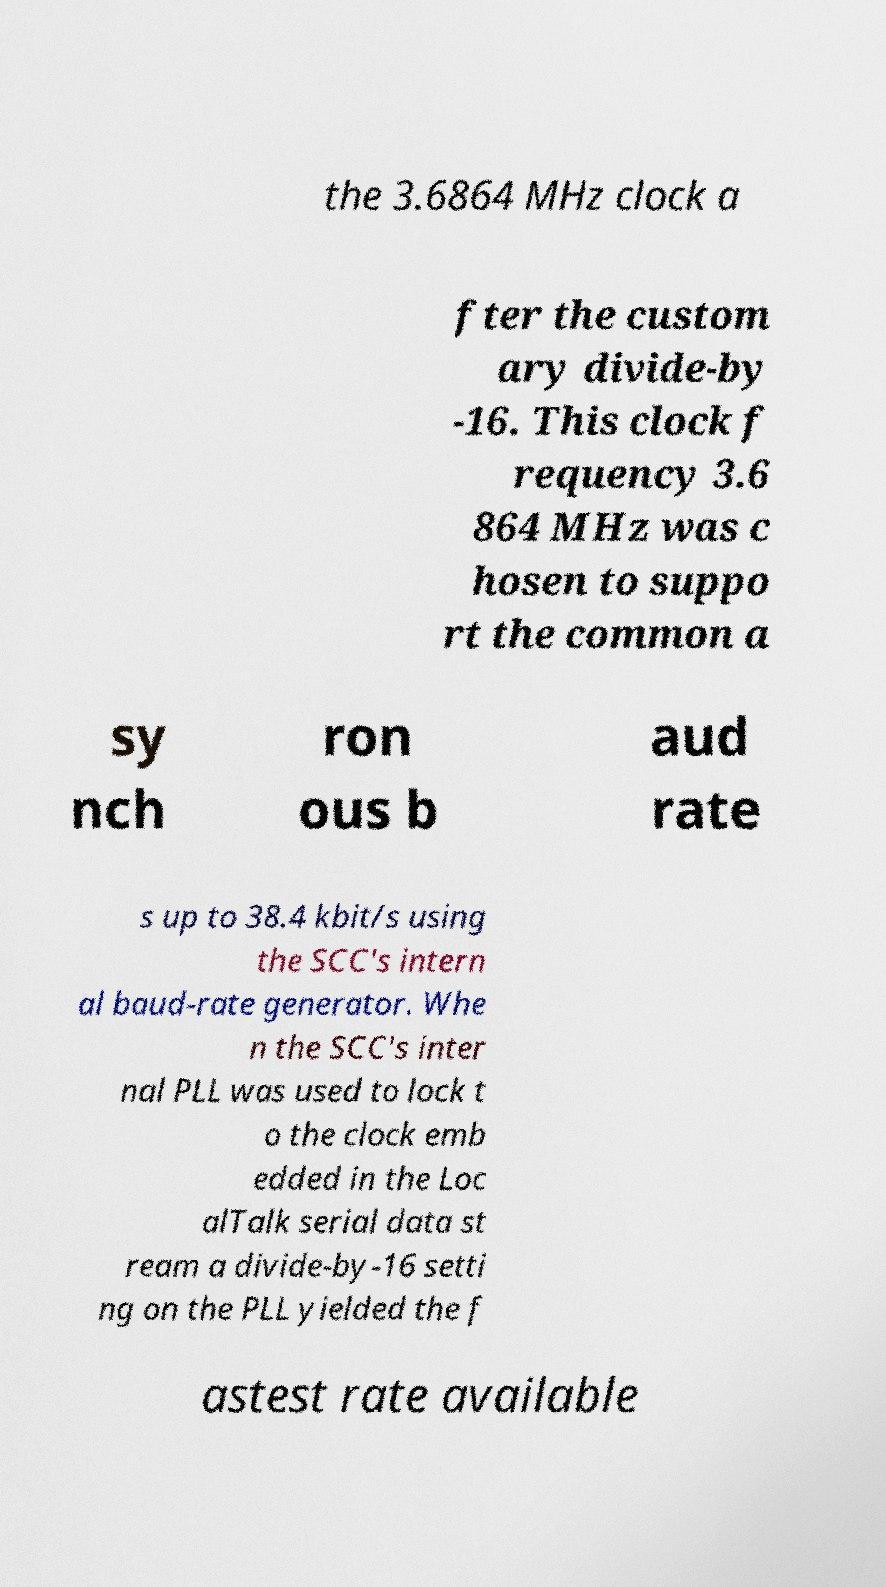Could you assist in decoding the text presented in this image and type it out clearly? the 3.6864 MHz clock a fter the custom ary divide-by -16. This clock f requency 3.6 864 MHz was c hosen to suppo rt the common a sy nch ron ous b aud rate s up to 38.4 kbit/s using the SCC's intern al baud-rate generator. Whe n the SCC's inter nal PLL was used to lock t o the clock emb edded in the Loc alTalk serial data st ream a divide-by-16 setti ng on the PLL yielded the f astest rate available 